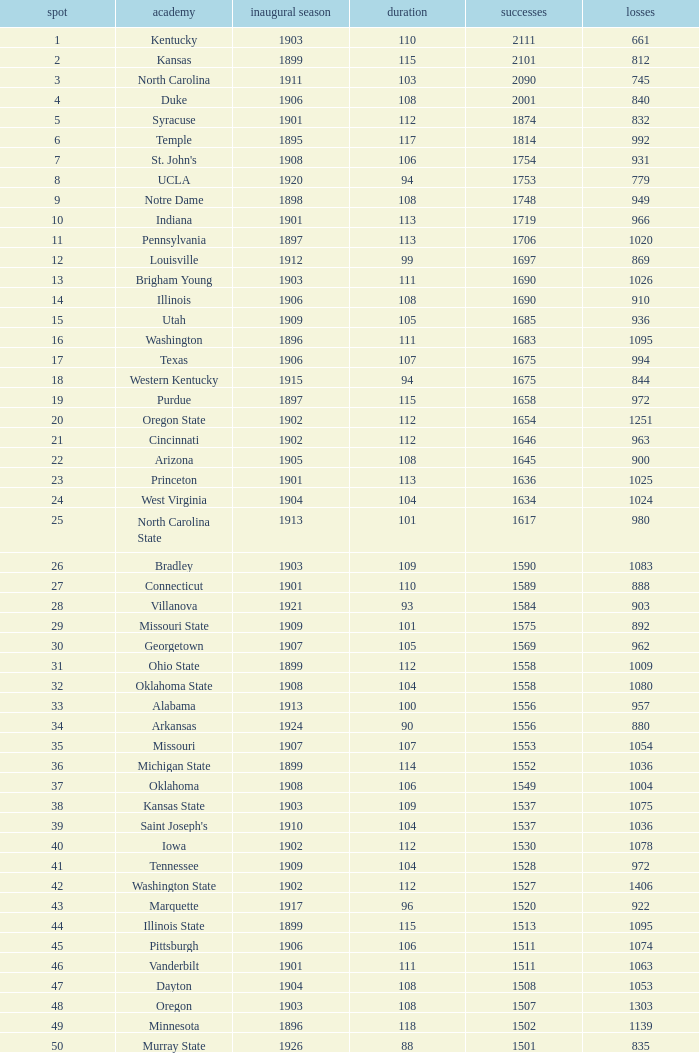What is the total of First Season games with 1537 Wins and a Season greater than 109? None. 